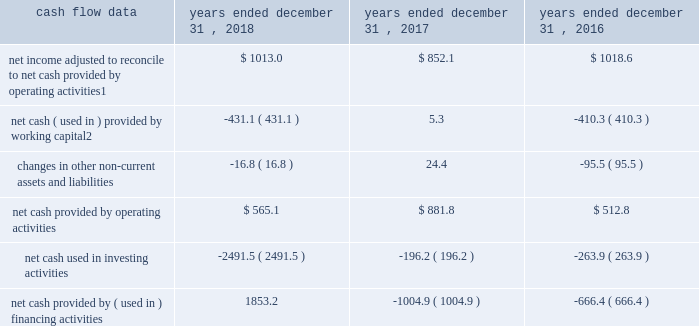Management 2019s discussion and analysis of financial condition and results of operations 2013 ( continued ) ( amounts in millions , except per share amounts ) liquidity and capital resources cash flow overview the tables summarize key financial data relating to our liquidity , capital resources and uses of capital. .
1 reflects net income adjusted primarily for depreciation and amortization of fixed assets and intangible assets , amortization of restricted stock and other non-cash compensation , net losses on sales of businesses and deferred income taxes .
2 reflects changes in accounts receivable , accounts receivable billable to clients , other current assets , accounts payable and accrued liabilities .
Operating activities due to the seasonality of our business , we typically use cash from working capital in the first nine months of a year , with the largest impact in the first quarter , and generate cash from working capital in the fourth quarter , driven by the seasonally strong media spending by our clients .
Quarterly and annual working capital results are impacted by the fluctuating annual media spending budgets of our clients as well as their changing media spending patterns throughout each year across various countries .
The timing of media buying on behalf of our clients across various countries affects our working capital and operating cash flow and can be volatile .
In most of our businesses , our agencies enter into commitments to pay production and media costs on behalf of clients .
To the extent possible , we pay production and media charges after we have received funds from our clients .
The amounts involved , which substantially exceed our revenues , primarily affect the level of accounts receivable , accounts payable , accrued liabilities and contract liabilities .
Our assets include both cash received and accounts receivable from clients for these pass-through arrangements , while our liabilities include amounts owed on behalf of clients to media and production suppliers .
Our accrued liabilities are also affected by the timing of certain other payments .
For example , while annual cash incentive awards are accrued throughout the year , they are generally paid during the first quarter of the subsequent year .
Net cash provided by operating activities during 2018 was $ 565.1 , which was a decrease of $ 316.7 as compared to 2017 , primarily as a result of an increase in working capital usage of $ 436.4 .
Working capital in 2018 was impacted by the spending levels of our clients as compared to 2017 .
The working capital usage in both periods was primarily attributable to our media businesses .
Net cash provided by operating activities during 2017 was $ 881.8 , which was an increase of $ 369.0 as compared to 2016 , primarily as a result of an improvement in working capital usage of $ 415.6 .
Working capital in 2017 benefited from the spending patterns of our clients compared to 2016 .
Investing activities net cash used in investing activities during 2018 consisted of payments for acquisitions of $ 2309.8 , related mostly to the acxiom acquisition , and payments for capital expenditures of $ 177.1 , related mostly to leasehold improvements and computer hardware and software. .
What was the percentage reduction of the net cash provided by operating activities from 2017 to 2018? 
Computations: (316.7 / 881.8)
Answer: 0.35915. 